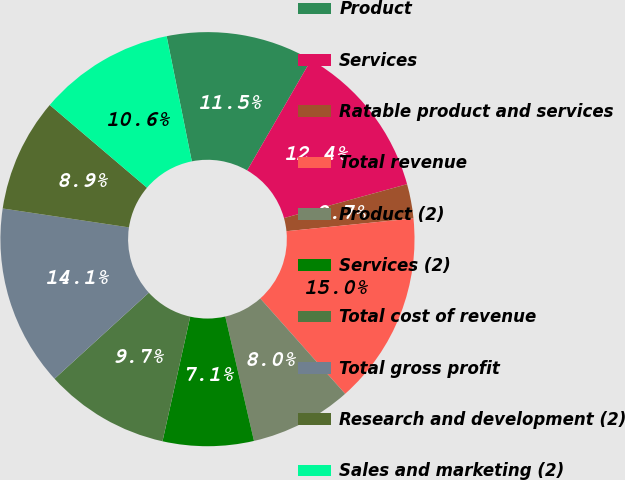<chart> <loc_0><loc_0><loc_500><loc_500><pie_chart><fcel>Product<fcel>Services<fcel>Ratable product and services<fcel>Total revenue<fcel>Product (2)<fcel>Services (2)<fcel>Total cost of revenue<fcel>Total gross profit<fcel>Research and development (2)<fcel>Sales and marketing (2)<nl><fcel>11.5%<fcel>12.38%<fcel>2.68%<fcel>15.02%<fcel>7.97%<fcel>7.09%<fcel>9.74%<fcel>14.14%<fcel>8.85%<fcel>10.62%<nl></chart> 